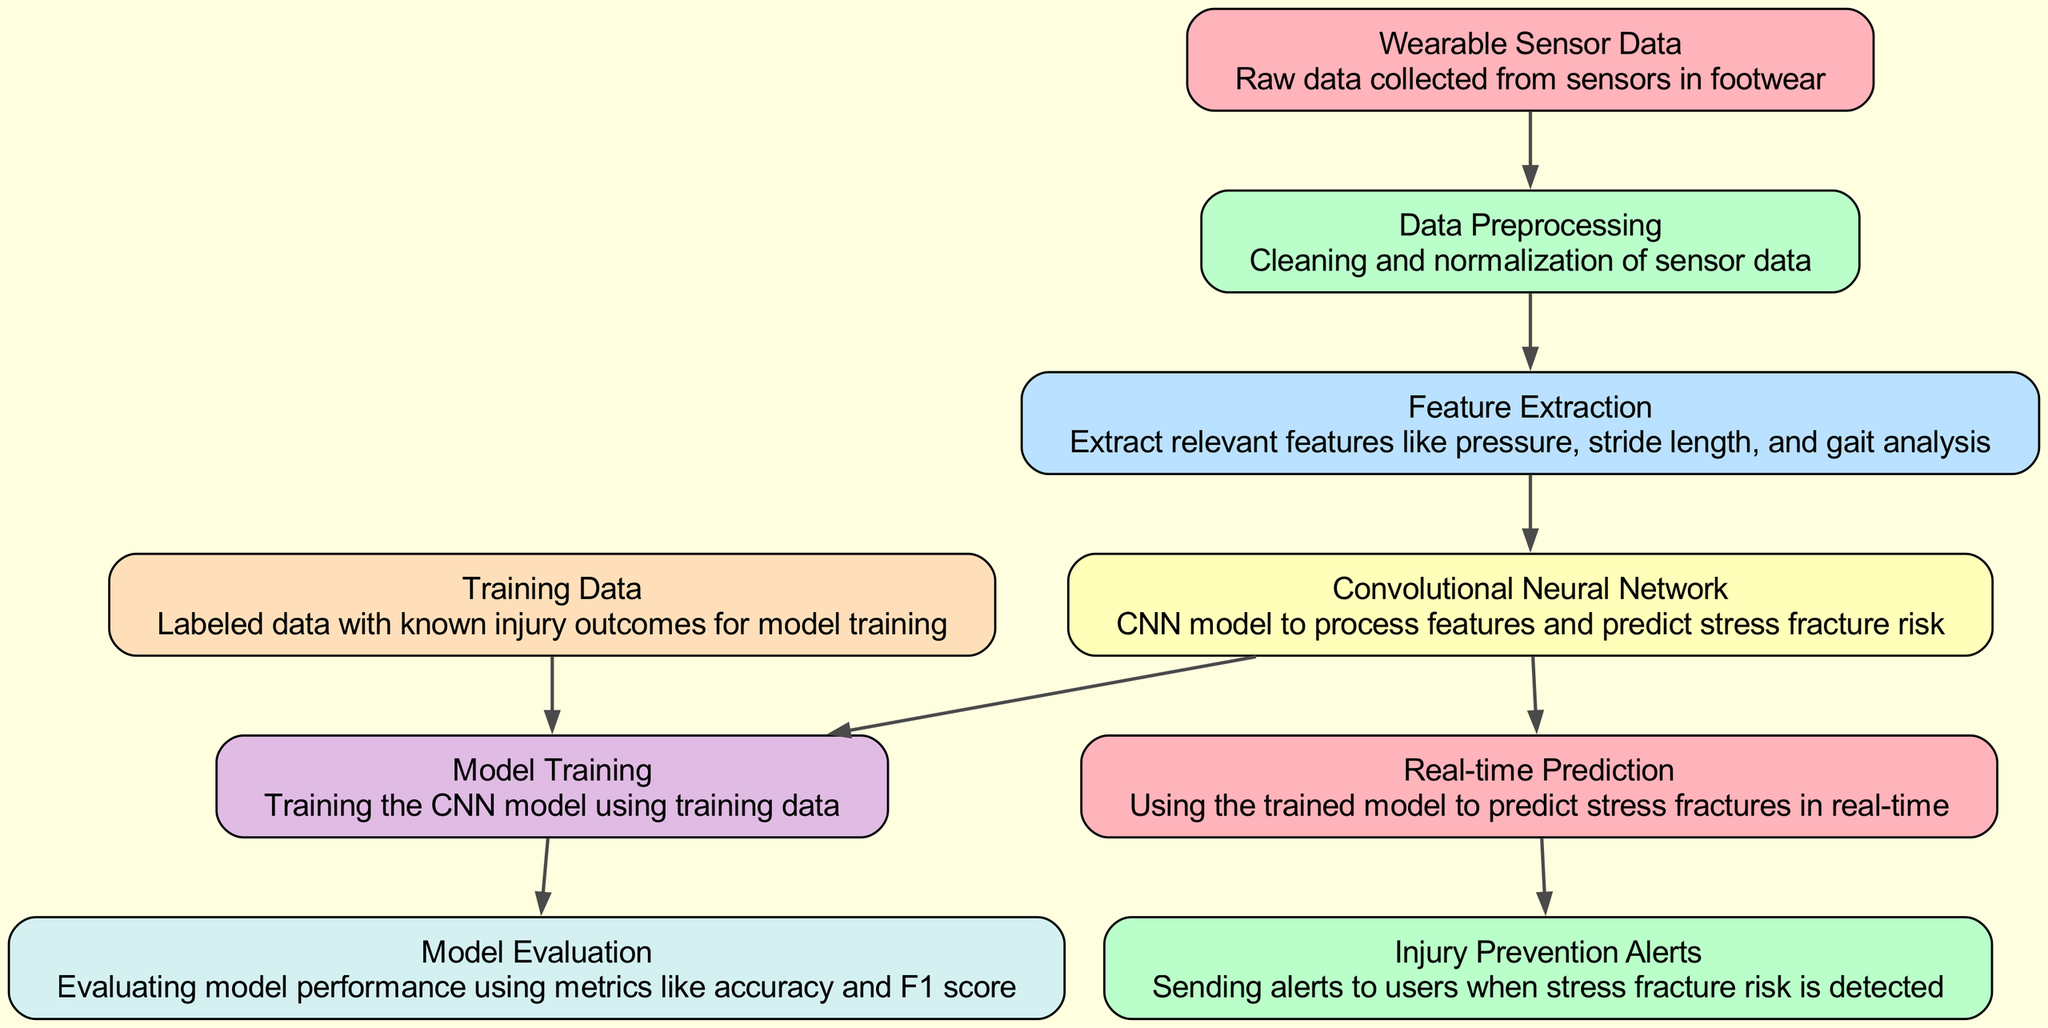What is the first node in the diagram? The first node, labeled "Wearable Sensor Data," is the starting point in the diagram. It represents the raw data collected from sensors in footwear.
Answer: Wearable Sensor Data How many nodes are present in the diagram? By counting each node listed in the data, we can find that there are a total of 9 nodes.
Answer: 9 Which node describes "cleaning and normalization of sensor data"? The node labeled "Data Preprocessing" directly corresponds to the description "cleaning and normalization of sensor data."
Answer: Data Preprocessing What is the relationship between "Feature Extraction" and "Convolutional Neural Network"? The edge indicates that "Feature Extraction" feeds directly into the "Convolutional Neural Network," meaning extracted features are used as input for the CNN.
Answer: Input What metrics are mentioned in the "Model Evaluation" node? The "Model Evaluation" node mentions evaluating model performance using metrics like accuracy and F1 score. This indicates the criteria used to assess the CNN model's effectiveness.
Answer: Accuracy, F1 score Which process follows after "Model Training"? The diagram indicates that "Model Evaluation" is the next process following "Model Training," where the performance of the CNN model is assessed.
Answer: Model Evaluation How does real-time prediction take place in the diagram? The "Real-time Prediction" node is activated using the outputs from the "Convolutional Neural Network," showing that the trained model is employed to make predictions.
Answer: Convolutional Neural Network What alerts are generated after detecting a stress fracture risk? The node labeled "Injury Prevention Alerts" indicates that alerts are sent to users when a stress fracture risk is detected, providing a safety mechanism.
Answer: Alerts What connects "Training Data" to "Model Training"? An edge connects "Training Data" directly to "Model Training," indicating that labeled data with known injury outcomes serves as the basis for training the model.
Answer: Training Data 